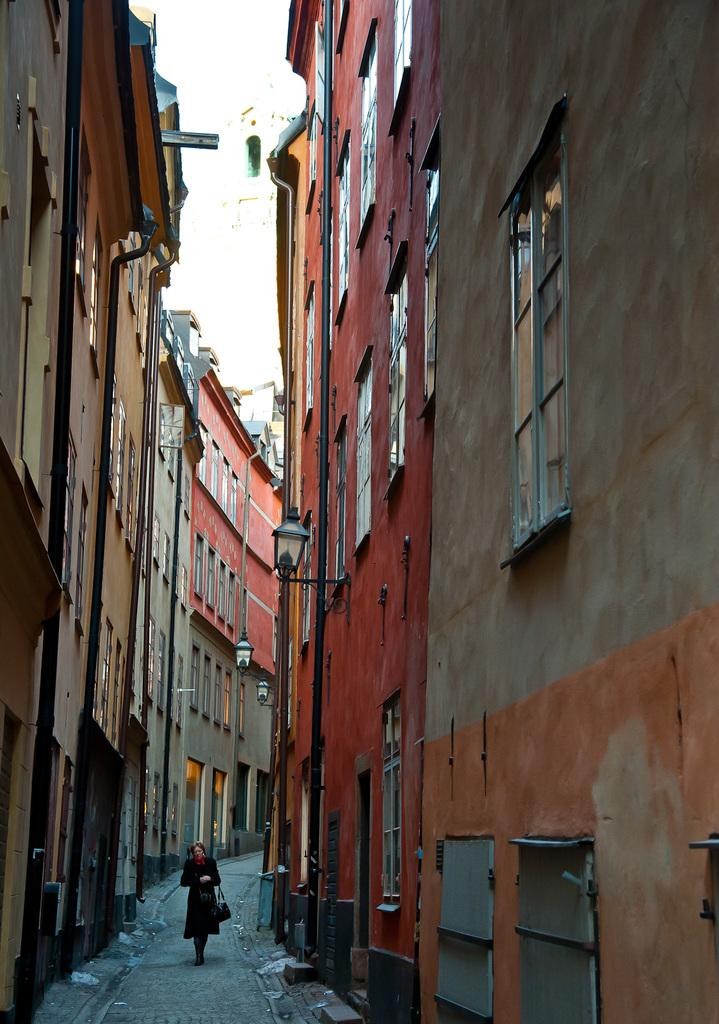What can be seen in the image that people might walk on? There is a path in the image that a woman is walking on. What is the woman doing on the path? The woman is walking on the path. What can be seen on either side of the path? There are buildings on either side of the path. Where is the throne located in the image? There is no throne present in the image. What type of paper can be seen on the path? There is no paper visible on the path in the image. 